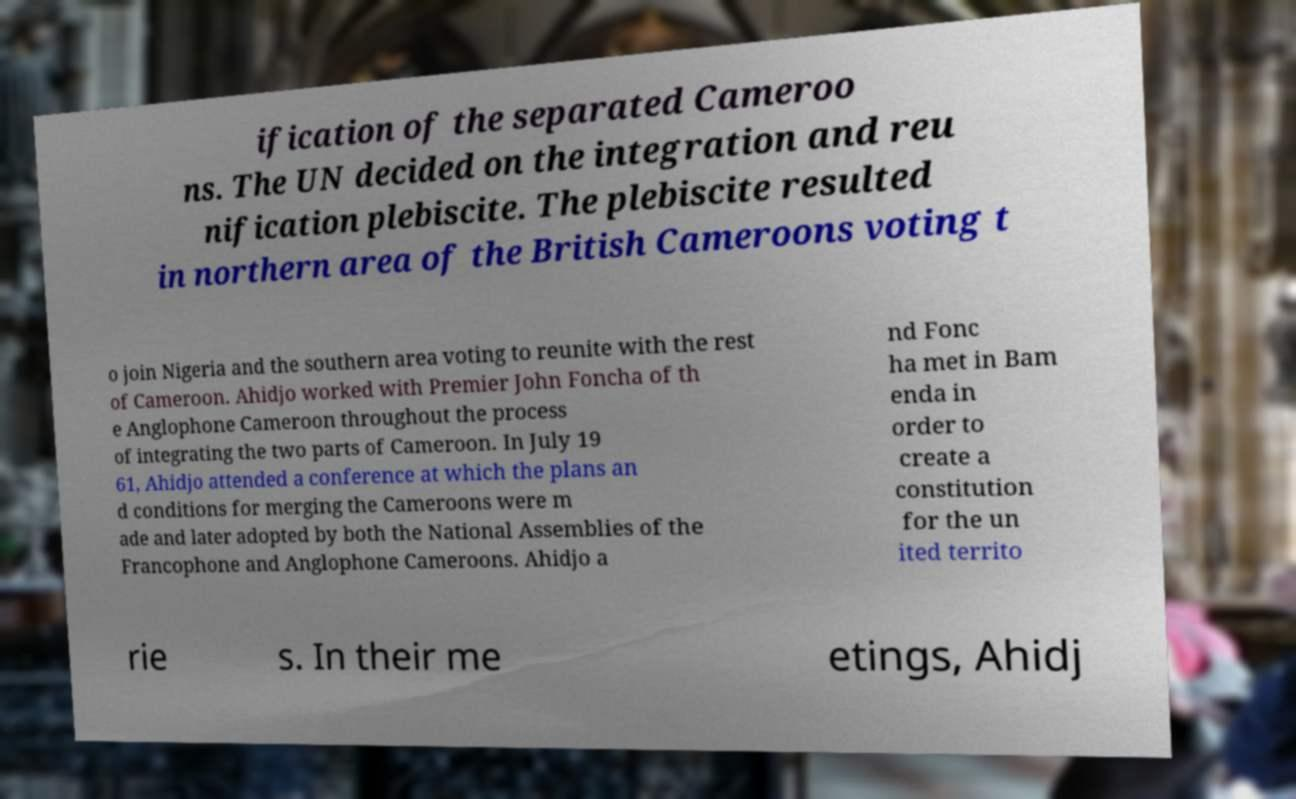I need the written content from this picture converted into text. Can you do that? ification of the separated Cameroo ns. The UN decided on the integration and reu nification plebiscite. The plebiscite resulted in northern area of the British Cameroons voting t o join Nigeria and the southern area voting to reunite with the rest of Cameroon. Ahidjo worked with Premier John Foncha of th e Anglophone Cameroon throughout the process of integrating the two parts of Cameroon. In July 19 61, Ahidjo attended a conference at which the plans an d conditions for merging the Cameroons were m ade and later adopted by both the National Assemblies of the Francophone and Anglophone Cameroons. Ahidjo a nd Fonc ha met in Bam enda in order to create a constitution for the un ited territo rie s. In their me etings, Ahidj 